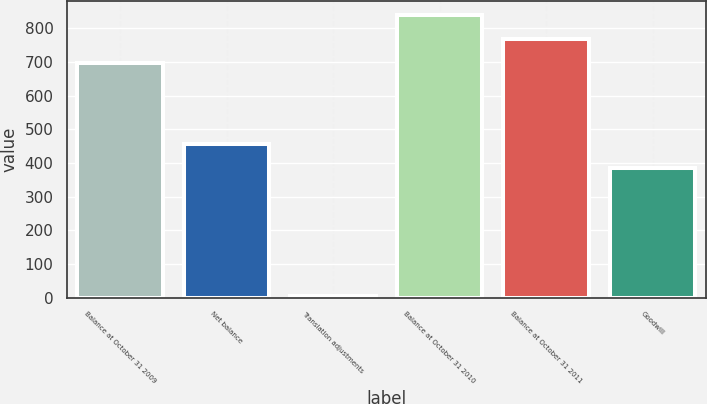<chart> <loc_0><loc_0><loc_500><loc_500><bar_chart><fcel>Balance at October 31 2009<fcel>Net balance<fcel>Translation adjustments<fcel>Balance at October 31 2010<fcel>Balance at October 31 2011<fcel>Goodwill<nl><fcel>698<fcel>454.9<fcel>6<fcel>837.8<fcel>767.9<fcel>385<nl></chart> 